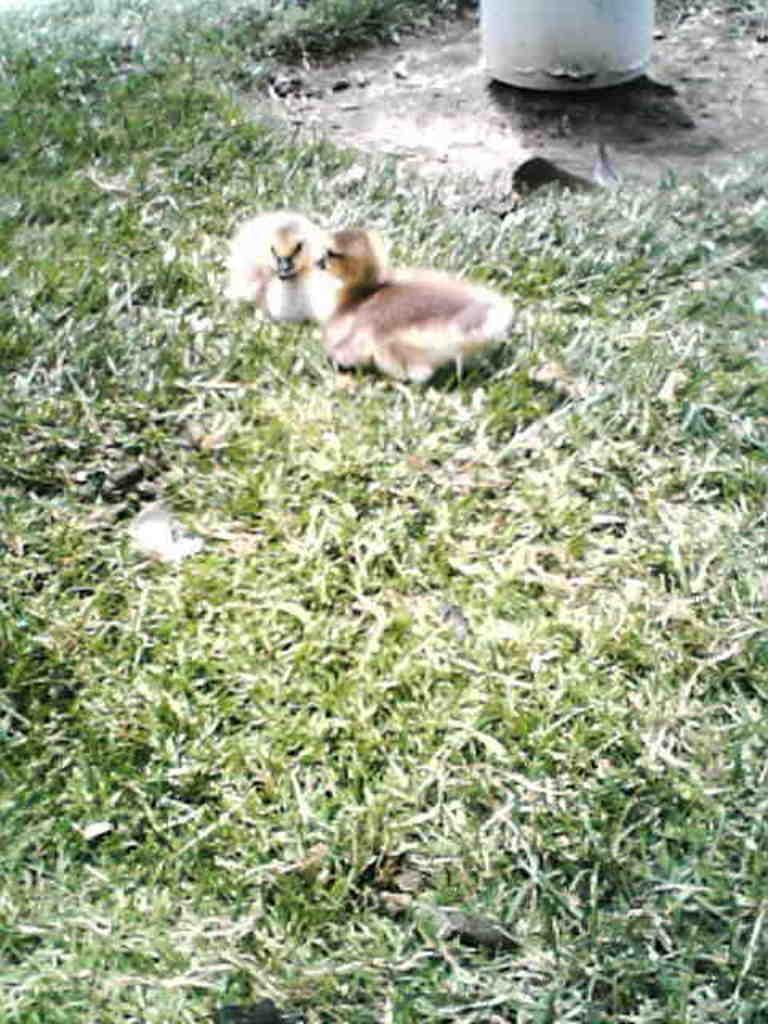What animals are in the center of the picture? There are two ducklings in the center of the picture. What type of vegetation is visible in the foreground of the image? There is grass in the foreground of the image. Is there any grass visible in other parts of the image? Yes, there is grass at the top of the image. What object can be seen at the top of the image? There is an object at the top of the image. What type of wrench is hanging from the icicle in the image? There is no wrench or icicle present in the image. Is there a chair visible in the image? There is no chair visible in the image. 